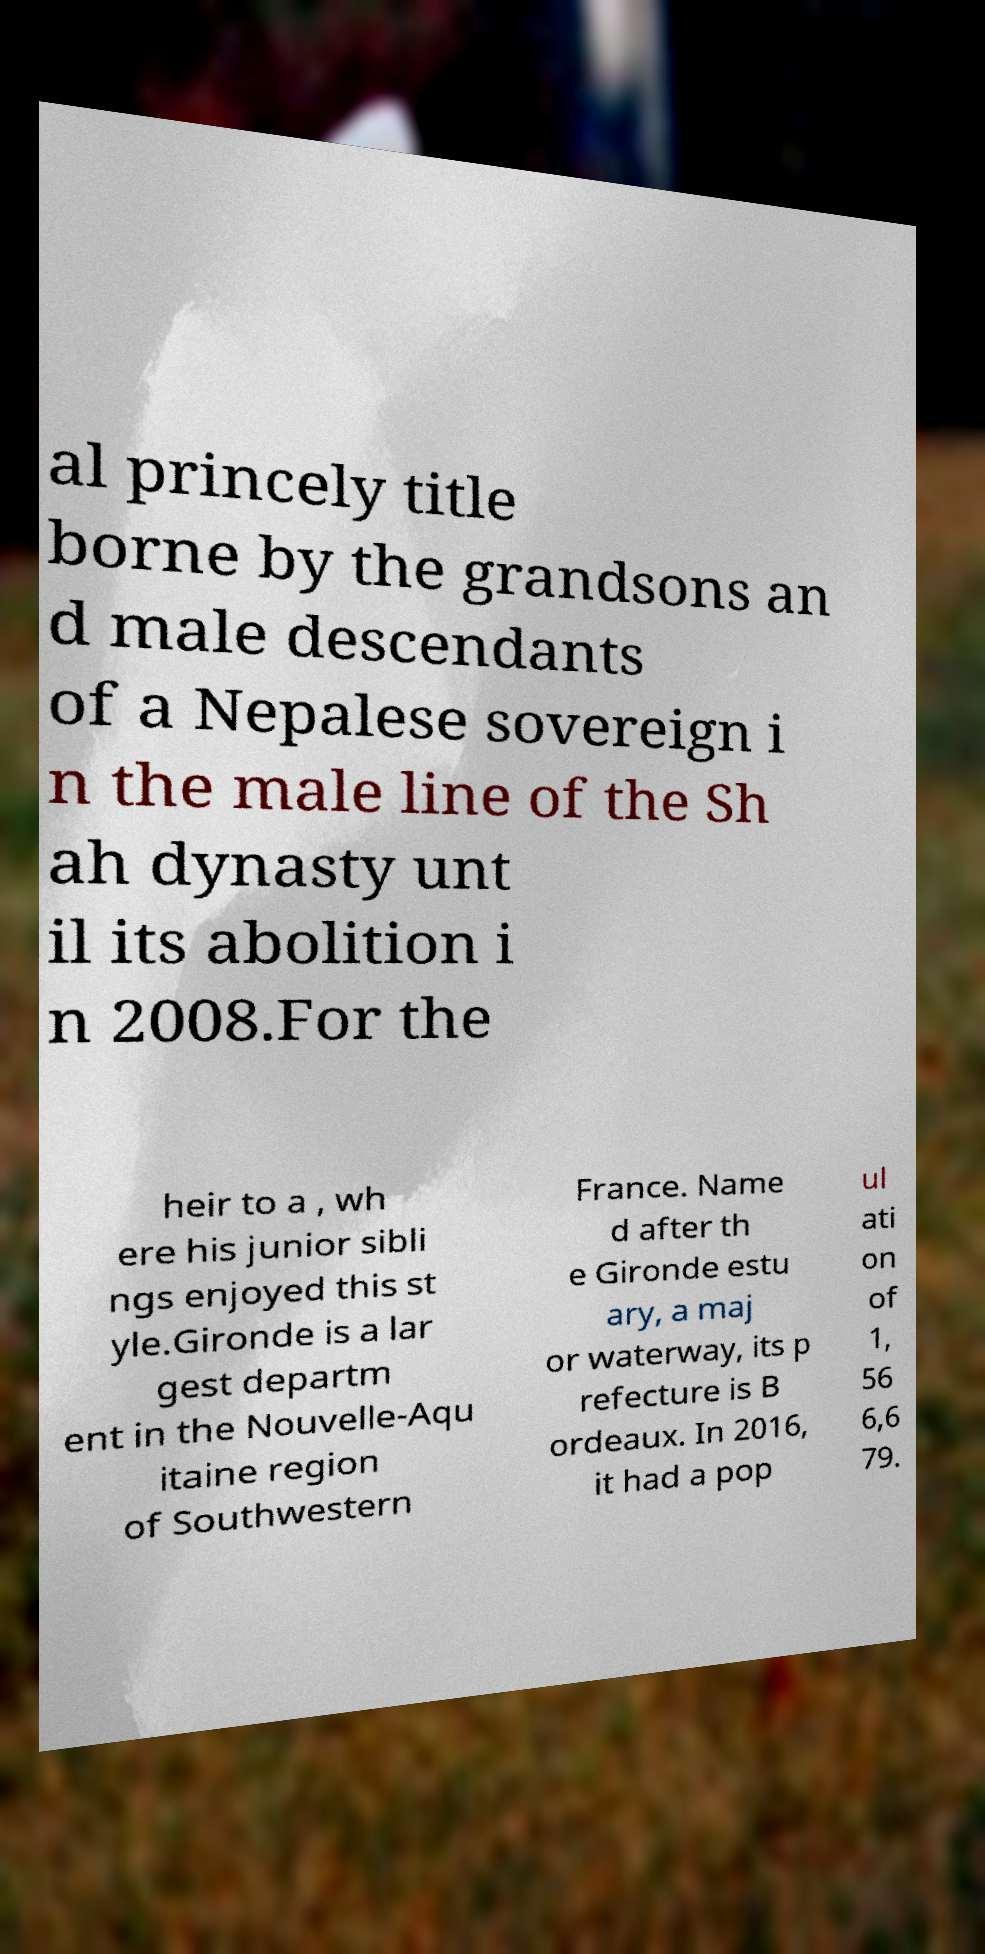There's text embedded in this image that I need extracted. Can you transcribe it verbatim? al princely title borne by the grandsons an d male descendants of a Nepalese sovereign i n the male line of the Sh ah dynasty unt il its abolition i n 2008.For the heir to a , wh ere his junior sibli ngs enjoyed this st yle.Gironde is a lar gest departm ent in the Nouvelle-Aqu itaine region of Southwestern France. Name d after th e Gironde estu ary, a maj or waterway, its p refecture is B ordeaux. In 2016, it had a pop ul ati on of 1, 56 6,6 79. 